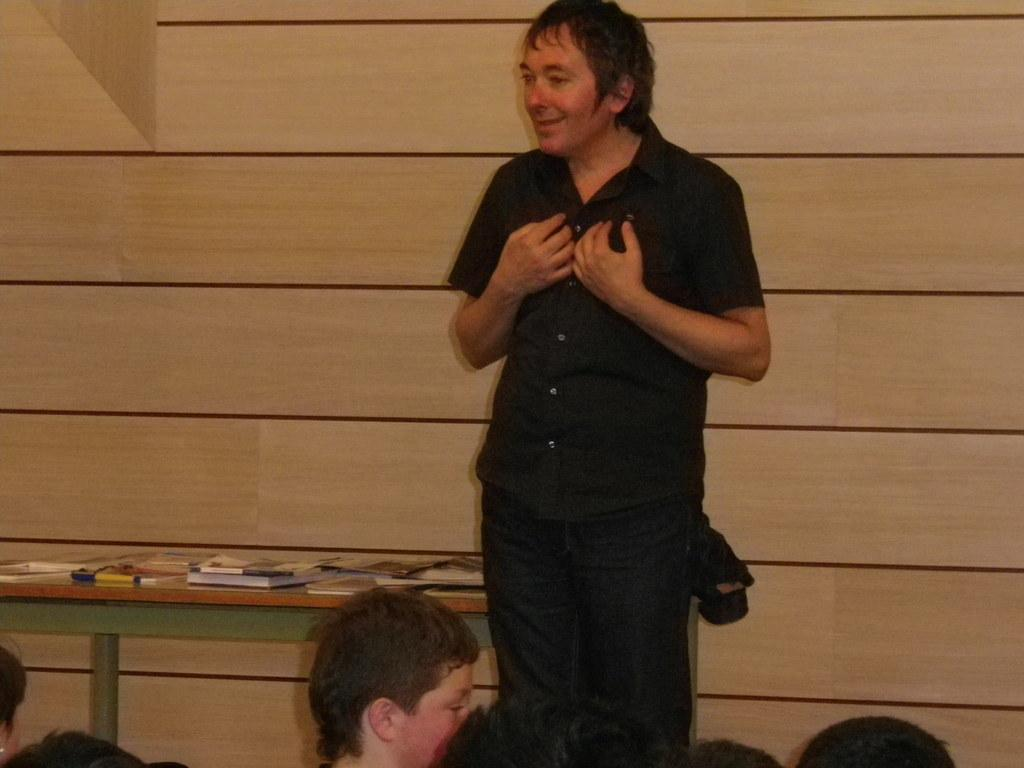What can be seen in the image involving multiple individuals? There is a group of people in the image. Can you describe the man's demeanor in the image? A man is standing and smiling in the image. What is on the table in the image? There is a table with books on it in the image. What is visible in the background of the image? There is a wall in the background of the image. What is the price of the books on the table in the image? The provided facts do not mention any prices, so we cannot determine the price of the books in the image. What type of pleasure can be seen on the faces of the people in the image? The provided facts do not mention any expressions on the faces of the people other than the man's smile, so we cannot determine the type of pleasure on their faces. 